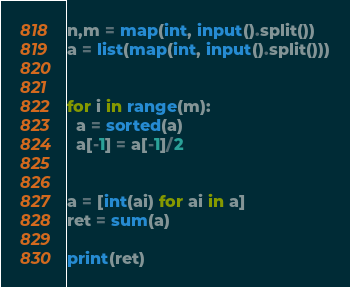Convert code to text. <code><loc_0><loc_0><loc_500><loc_500><_Python_>

n,m = map(int, input().split())
a = list(map(int, input().split()))


for i in range(m):
  a = sorted(a)
  a[-1] = a[-1]/2


a = [int(ai) for ai in a]
ret = sum(a)

print(ret)</code> 